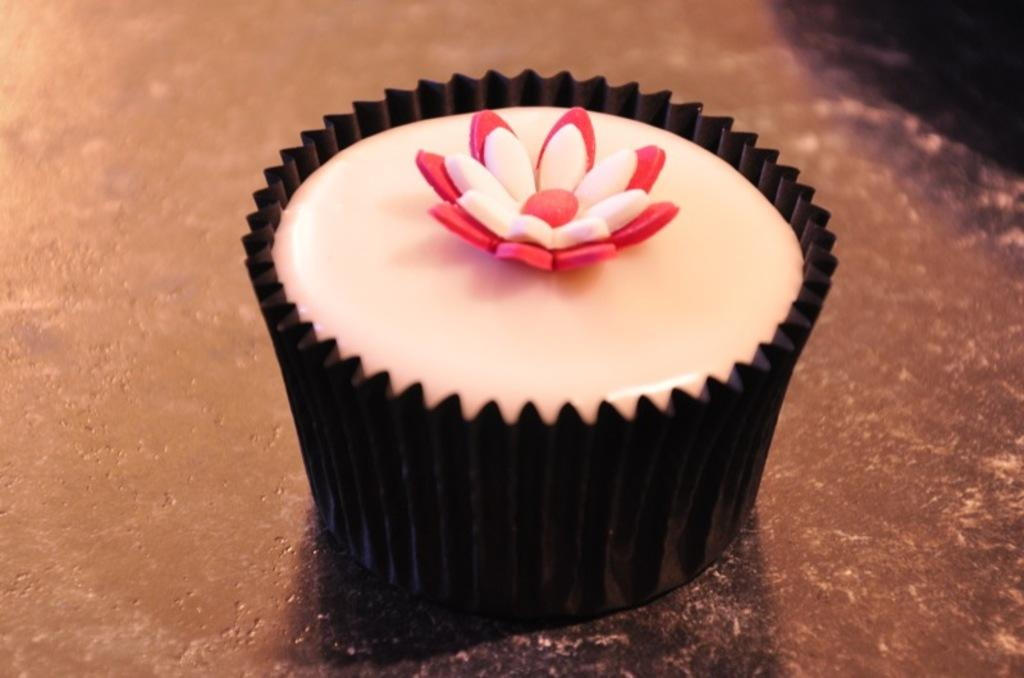What type of food is visible in the image? There is a cupcake in the image. What company is responsible for organizing the walk during the rainstorm in the image? There is no walk or rainstorm present in the image; it only features a cupcake. 